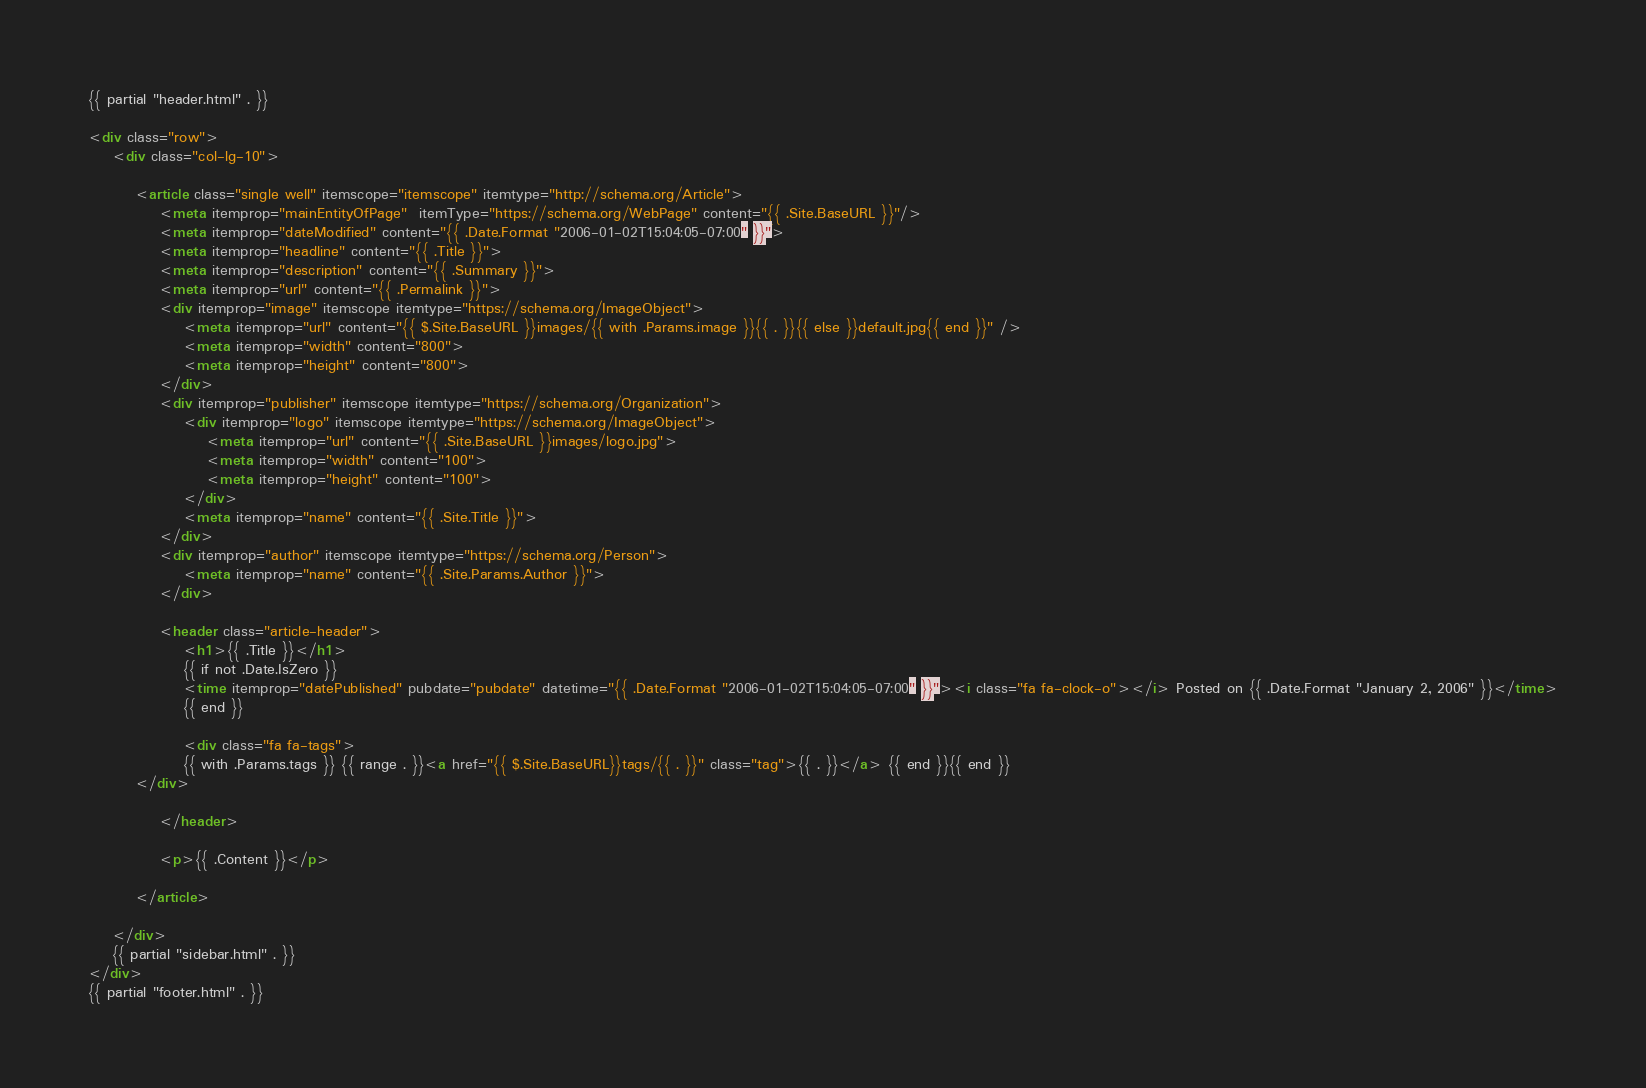Convert code to text. <code><loc_0><loc_0><loc_500><loc_500><_HTML_>{{ partial "header.html" . }}

<div class="row">
    <div class="col-lg-10">

        <article class="single well" itemscope="itemscope" itemtype="http://schema.org/Article">
            <meta itemprop="mainEntityOfPage"  itemType="https://schema.org/WebPage" content="{{ .Site.BaseURL }}"/>
            <meta itemprop="dateModified" content="{{ .Date.Format "2006-01-02T15:04:05-07:00" }}">
            <meta itemprop="headline" content="{{ .Title }}">
            <meta itemprop="description" content="{{ .Summary }}">
            <meta itemprop="url" content="{{ .Permalink }}">
            <div itemprop="image" itemscope itemtype="https://schema.org/ImageObject">
                <meta itemprop="url" content="{{ $.Site.BaseURL }}images/{{ with .Params.image }}{{ . }}{{ else }}default.jpg{{ end }}" />
                <meta itemprop="width" content="800">
                <meta itemprop="height" content="800">
            </div>
            <div itemprop="publisher" itemscope itemtype="https://schema.org/Organization">
                <div itemprop="logo" itemscope itemtype="https://schema.org/ImageObject">
                    <meta itemprop="url" content="{{ .Site.BaseURL }}images/logo.jpg">
                    <meta itemprop="width" content="100">
                    <meta itemprop="height" content="100">
                </div>
                <meta itemprop="name" content="{{ .Site.Title }}">
            </div>
            <div itemprop="author" itemscope itemtype="https://schema.org/Person">
                <meta itemprop="name" content="{{ .Site.Params.Author }}">
            </div>

            <header class="article-header">
                <h1>{{ .Title }}</h1>
                {{ if not .Date.IsZero }}
                <time itemprop="datePublished" pubdate="pubdate" datetime="{{ .Date.Format "2006-01-02T15:04:05-07:00" }}"><i class="fa fa-clock-o"></i> Posted on {{ .Date.Format "January 2, 2006" }}</time>
                {{ end }}

                <div class="fa fa-tags">
                {{ with .Params.tags }} {{ range . }}<a href="{{ $.Site.BaseURL}}tags/{{ . }}" class="tag">{{ . }}</a> {{ end }}{{ end }}
		</div>

            </header>

            <p>{{ .Content }}</p>

        </article>

    </div>
    {{ partial "sidebar.html" . }}
</div>
{{ partial "footer.html" . }}
</code> 